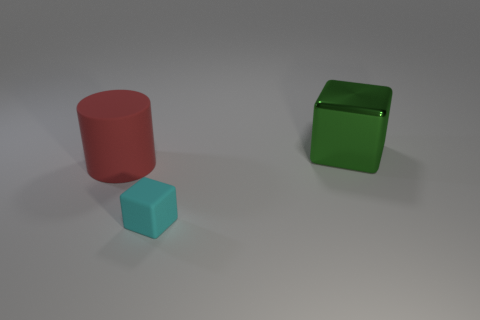Add 1 big metal cubes. How many objects exist? 4 Subtract all green cubes. How many cubes are left? 1 Subtract all cubes. How many objects are left? 1 Subtract 1 blocks. How many blocks are left? 1 Subtract all green cylinders. Subtract all brown cubes. How many cylinders are left? 1 Subtract all metal blocks. Subtract all small matte things. How many objects are left? 1 Add 1 cyan objects. How many cyan objects are left? 2 Add 1 big cylinders. How many big cylinders exist? 2 Subtract 0 brown cylinders. How many objects are left? 3 